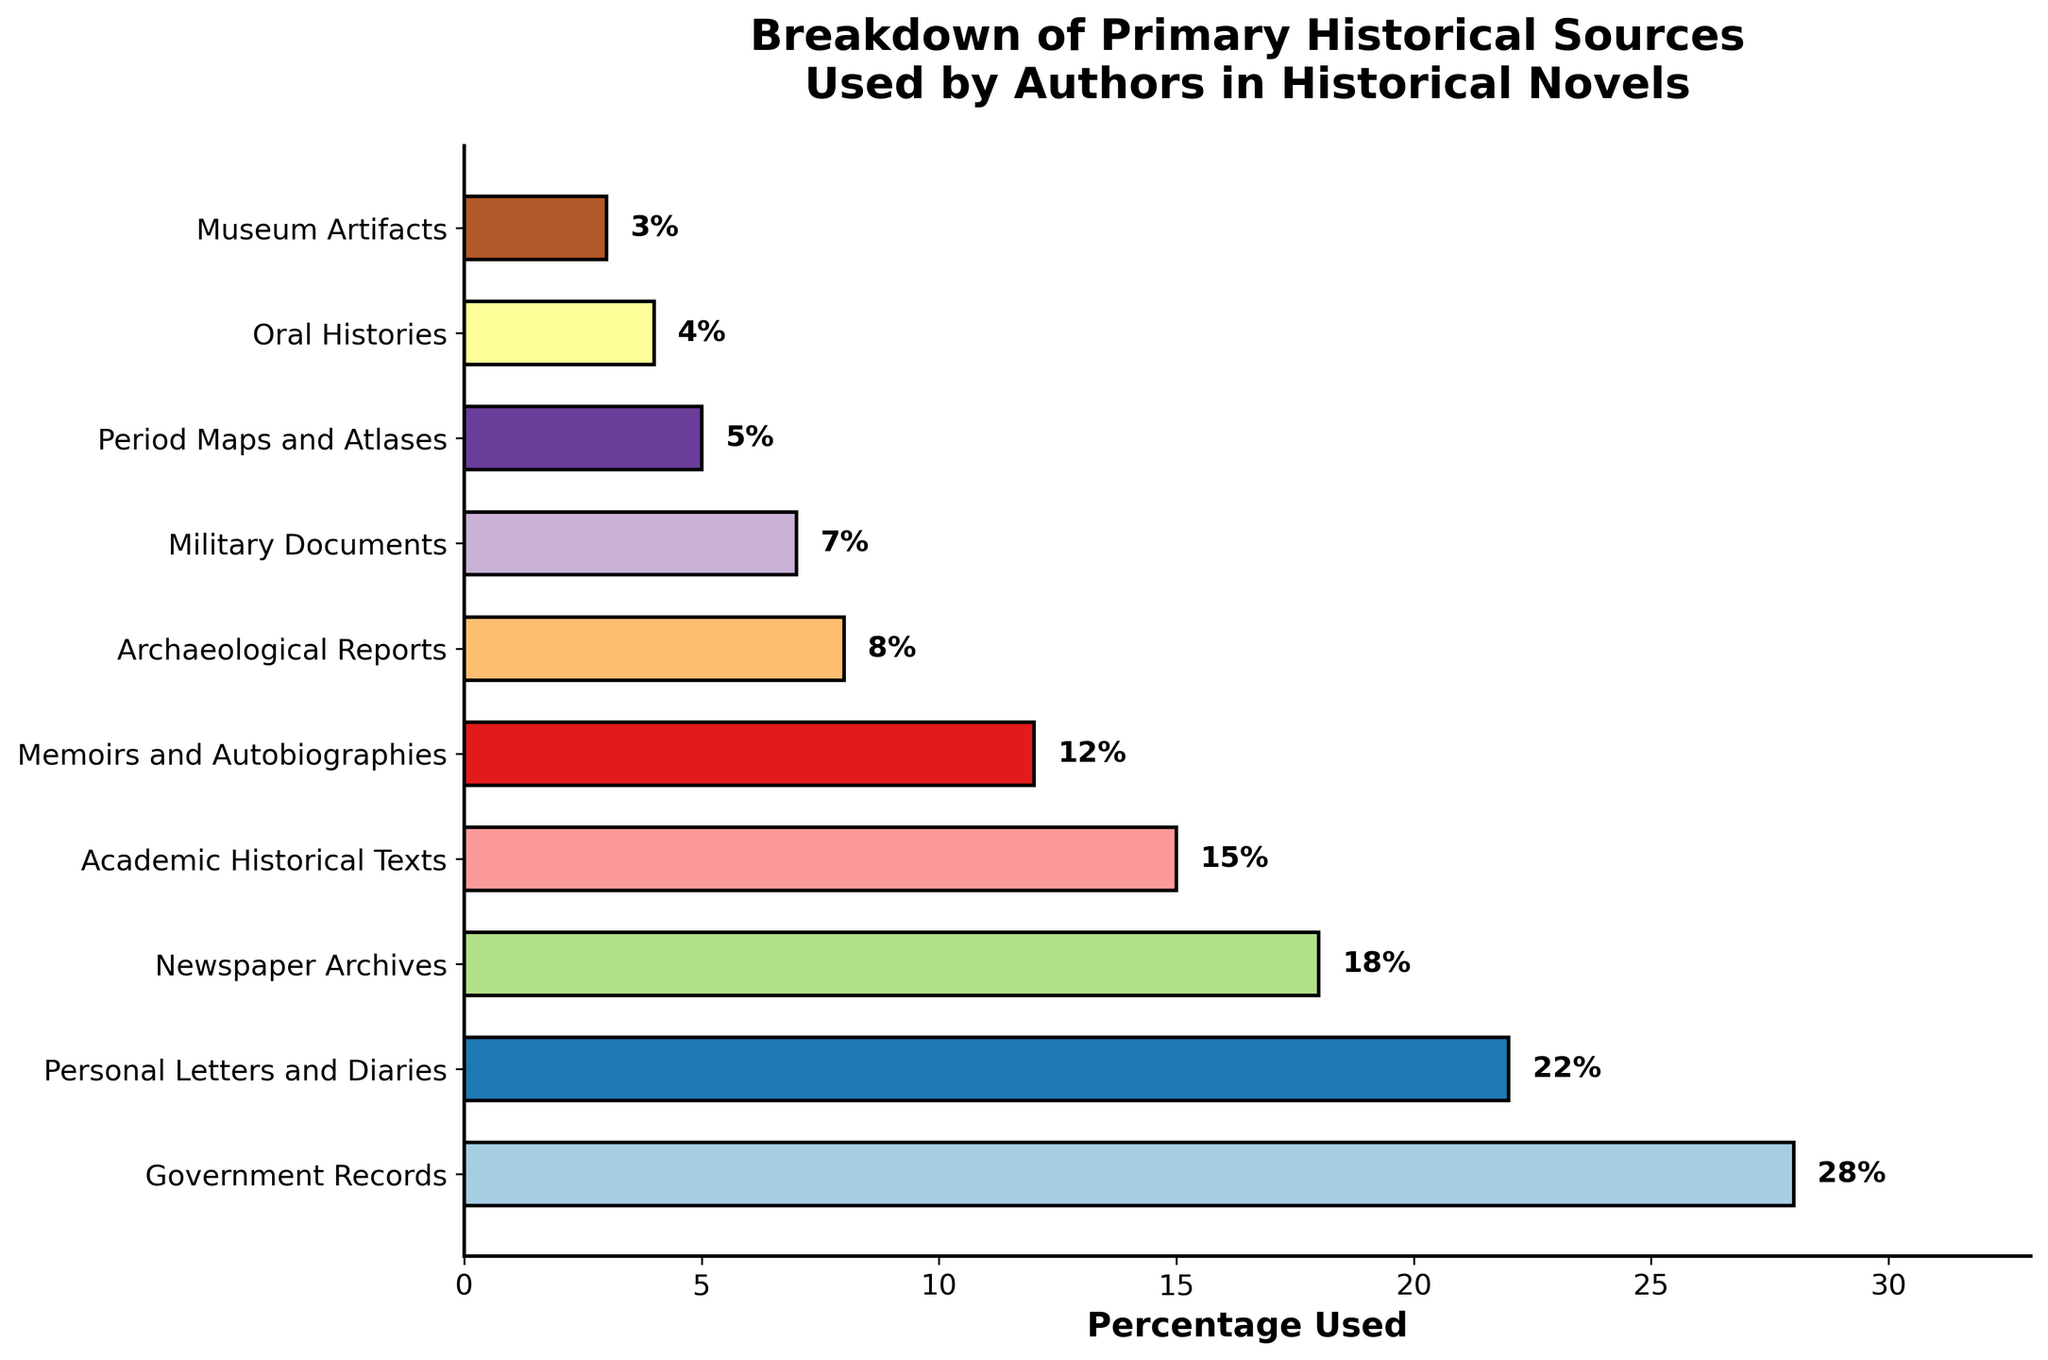Which historical source is used the most by authors? By observing the length of the bars and the percentage labels, we see that Government Records has the highest value of 28%.
Answer: Government Records What is the difference in usage percentage between the top two historical sources? Government Records are used 28% of the time and Personal Letters and Diaries 22%. The difference is calculated by subtracting the lower percentage from the higher percentage: 28% - 22% = 6%.
Answer: 6% Which source has a lower usage percentage: Newspaper Archives or Memoirs and Autobiographies? Examine the bars and find that Newspaper Archives have an 18% usage, while Memoirs and Autobiographies have 12%. The lower usage percentage is for Memoirs and Autobiographies.
Answer: Memoirs and Autobiographies What percentage of authors use sources other than Government Records, Personal Letters and Diaries, and Newspaper Archives combined? Sum of Government Records, Personal Letters and Diaries, and Newspaper Archives is 28% + 22% + 18% = 68%. Subtract from 100% gives 100% - 68% = 32%.
Answer: 32% How many more percentage points are Government Records used compared to Military Documents? Government Records are used 28%, and Military Documents 7%. The difference is computed by subtracting 7% from 28%, giving 28% - 7% = 21%.
Answer: 21% Identify the source with the shortest bar. By visually inspecting the bars, it's clear that Museum Artifacts have the shortest bar, representing 3%.
Answer: Museum Artifacts Which sources have a usage percent that is more than double that of Oral Histories? Oral Histories are used 4%. The sources with more than double this are those with greater than 8%: Government Records (28%), Personal Letters and Diaries (22%), Newspaper Archives (18%), Academic Historical Texts (15%), and Memoirs and Autobiographies (12%).
Answer: Government Records, Personal Letters and Diaries, Newspaper Archives, Academic Historical Texts, Memoirs and Autobiographies How many sources have a usage percentage greater than Archaeological Reports but less than Newspaper Archives? Archaeological Reports are at 8%, and Newspaper Archives at 18%. The sources within this range are Academic Historical Texts (15%) and Memoirs and Autobiographies (12%).
Answer: 2 Which sources collectively make up the bottom 30% of usage? Adding from the lowest percentages up: Museum Artifacts (3%) + Oral Histories (4%) + Period Maps and Atlases (5%) + Military Documents (7%) + Archaeological Reports (8%) yields a total of 27%. Adding Memoirs and Autobiographies (12%) would exceed 30%. Thus, the sources are Museum Artifacts, Oral Histories, Period Maps and Atlases, Military Documents, and Archaeological Reports.
Answer: Museum Artifacts, Oral Histories, Period Maps and Atlases, Military Documents, Archaeological Reports 